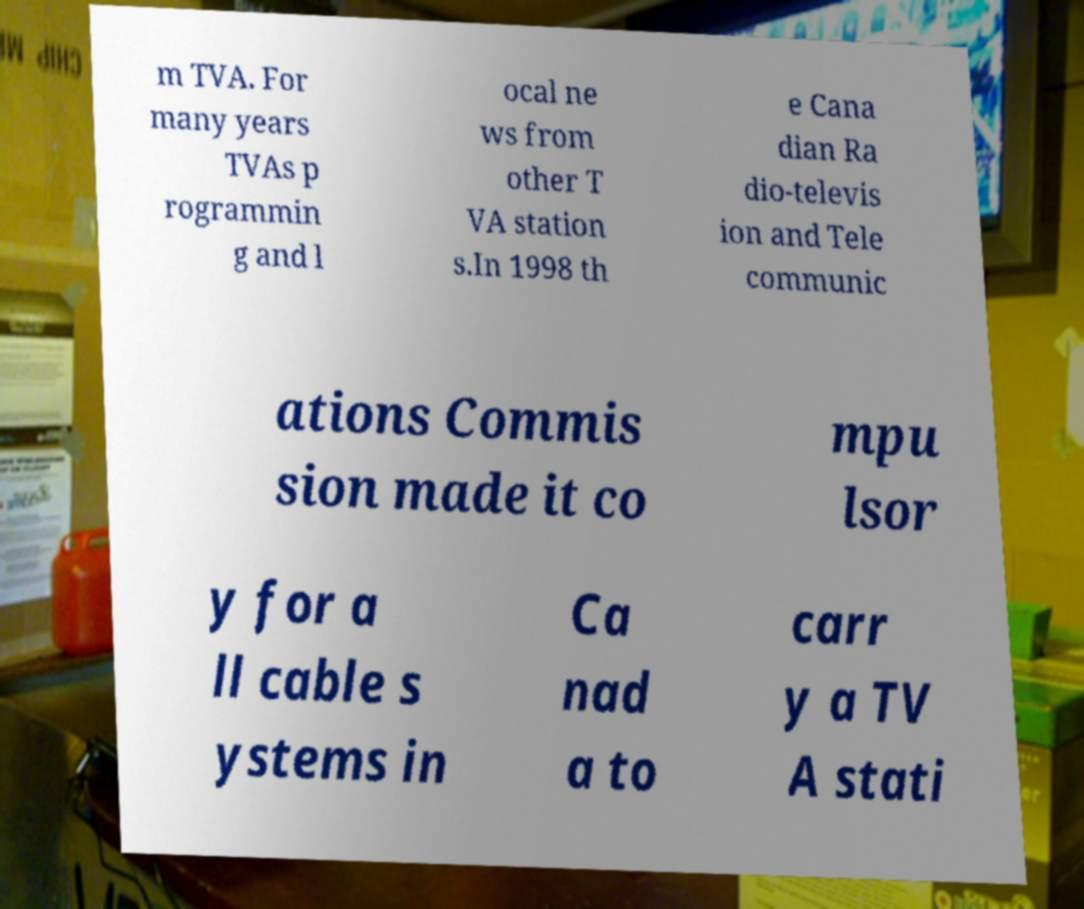I need the written content from this picture converted into text. Can you do that? m TVA. For many years TVAs p rogrammin g and l ocal ne ws from other T VA station s.In 1998 th e Cana dian Ra dio-televis ion and Tele communic ations Commis sion made it co mpu lsor y for a ll cable s ystems in Ca nad a to carr y a TV A stati 